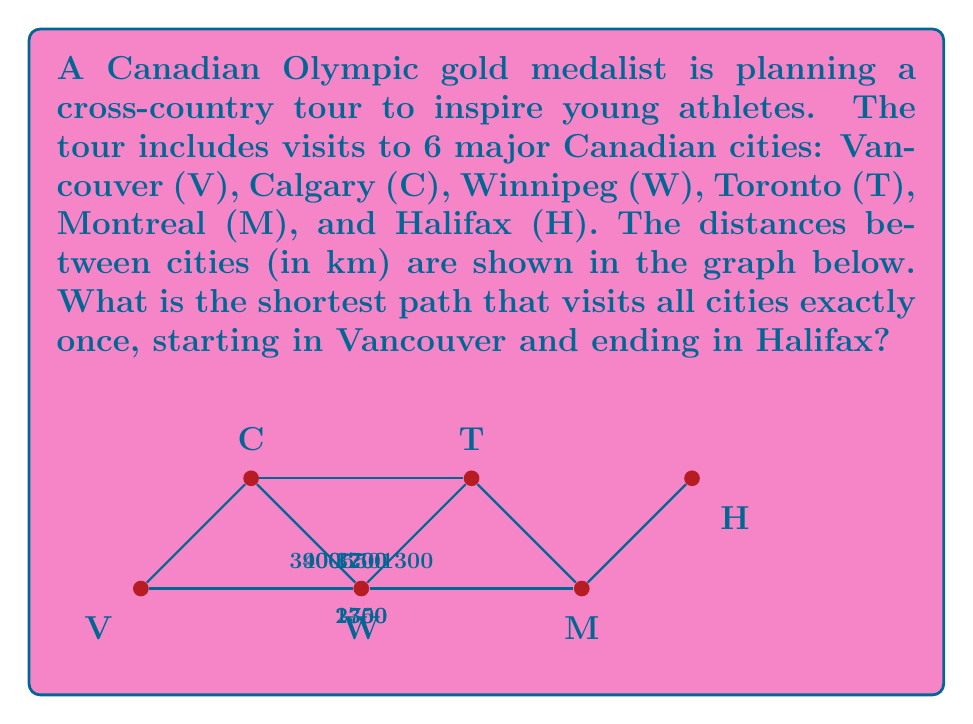What is the answer to this math problem? To solve this problem, we'll use Dijkstra's algorithm to find the shortest path from Vancouver to Halifax that visits all cities exactly once. We'll consider all possible routes and compare their total distances.

Step 1: List all possible routes from Vancouver to Halifax visiting each city once.
1. V-C-W-T-M-H
2. V-C-T-W-M-H
3. V-W-C-T-M-H
4. V-W-T-C-M-H
5. V-W-M-T-C-H

Step 2: Calculate the total distance for each route.

Route 1: V-C-W-T-M-H
$$ 3400 + 900 + 1300 + 550 + 1200 = 7350 \text{ km} $$

Route 2: V-C-T-W-M-H
$$ 3400 + 3700 + 1300 + 1700 + 1200 = 11300 \text{ km} $$

Route 3: V-W-C-T-M-H
$$ 2350 + 900 + 3700 + 550 + 1200 = 8700 \text{ km} $$

Route 4: V-W-T-C-M-H
$$ 2350 + 1300 + 3700 + 550 + 1200 = 9100 \text{ km} $$

Route 5: V-W-M-T-C-H
$$ 2350 + 1700 + 550 + 3700 + 1200 = 9500 \text{ km} $$

Step 3: Compare the total distances and identify the shortest path.

The shortest path is Route 1: V-C-W-T-M-H, with a total distance of 7350 km.
Answer: V-C-W-T-M-H, 7350 km 